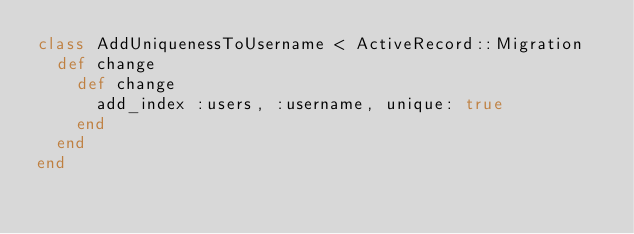Convert code to text. <code><loc_0><loc_0><loc_500><loc_500><_Ruby_>class AddUniquenessToUsername < ActiveRecord::Migration
  def change
    def change
      add_index :users, :username, unique: true
    end
  end
end
</code> 